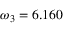<formula> <loc_0><loc_0><loc_500><loc_500>\omega _ { 3 } = 6 . 1 6 0</formula> 